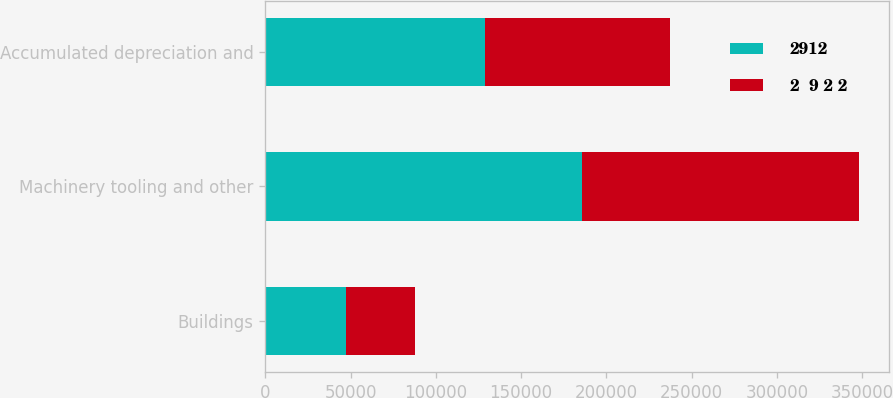Convert chart. <chart><loc_0><loc_0><loc_500><loc_500><stacked_bar_chart><ecel><fcel>Buildings<fcel>Machinery tooling and other<fcel>Accumulated depreciation and<nl><fcel>2912<fcel>47488<fcel>185663<fcel>129060<nl><fcel>2  9 2 2<fcel>40548<fcel>162501<fcel>108509<nl></chart> 